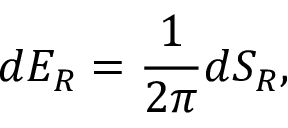Convert formula to latex. <formula><loc_0><loc_0><loc_500><loc_500>d E _ { R } = { \frac { 1 } { 2 \pi } } d S _ { R } ,</formula> 